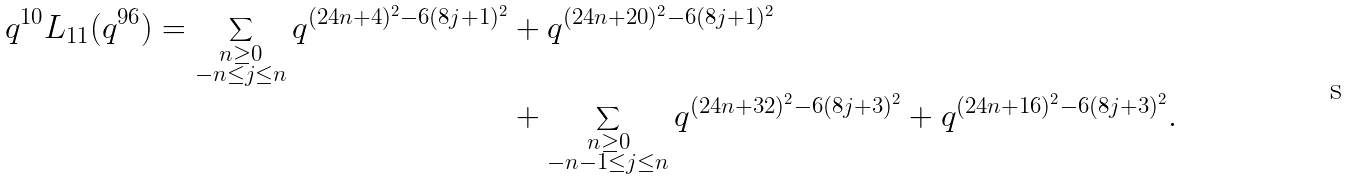Convert formula to latex. <formula><loc_0><loc_0><loc_500><loc_500>q ^ { 1 0 } L _ { 1 1 } ( q ^ { 9 6 } ) = \sum _ { \substack { n \geq 0 \\ - n \leq j \leq n } } q ^ { ( 2 4 n + 4 ) ^ { 2 } - 6 ( 8 j + 1 ) ^ { 2 } } & + q ^ { ( 2 4 n + 2 0 ) ^ { 2 } - 6 ( 8 j + 1 ) ^ { 2 } } \\ & + \sum _ { \substack { n \geq 0 \\ - n - 1 \leq j \leq n } } q ^ { ( 2 4 n + 3 2 ) ^ { 2 } - 6 ( 8 j + 3 ) ^ { 2 } } + q ^ { ( 2 4 n + 1 6 ) ^ { 2 } - 6 ( 8 j + 3 ) ^ { 2 } } .</formula> 